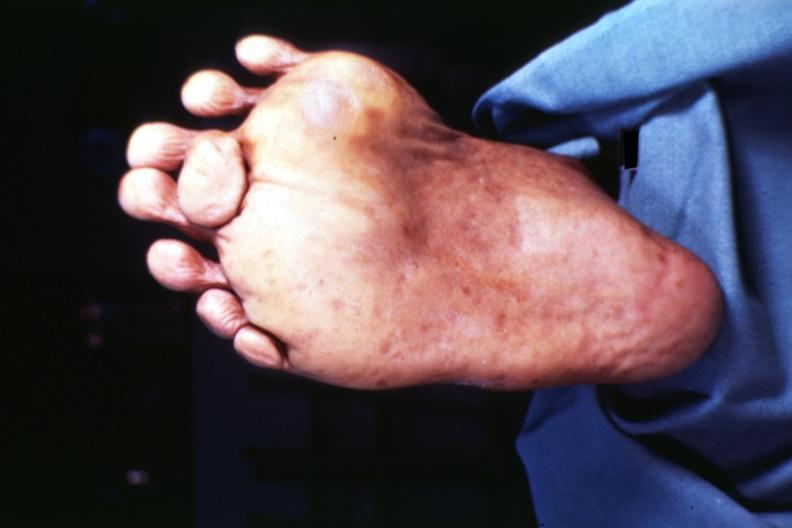re arachnodactyly present?
Answer the question using a single word or phrase. No 